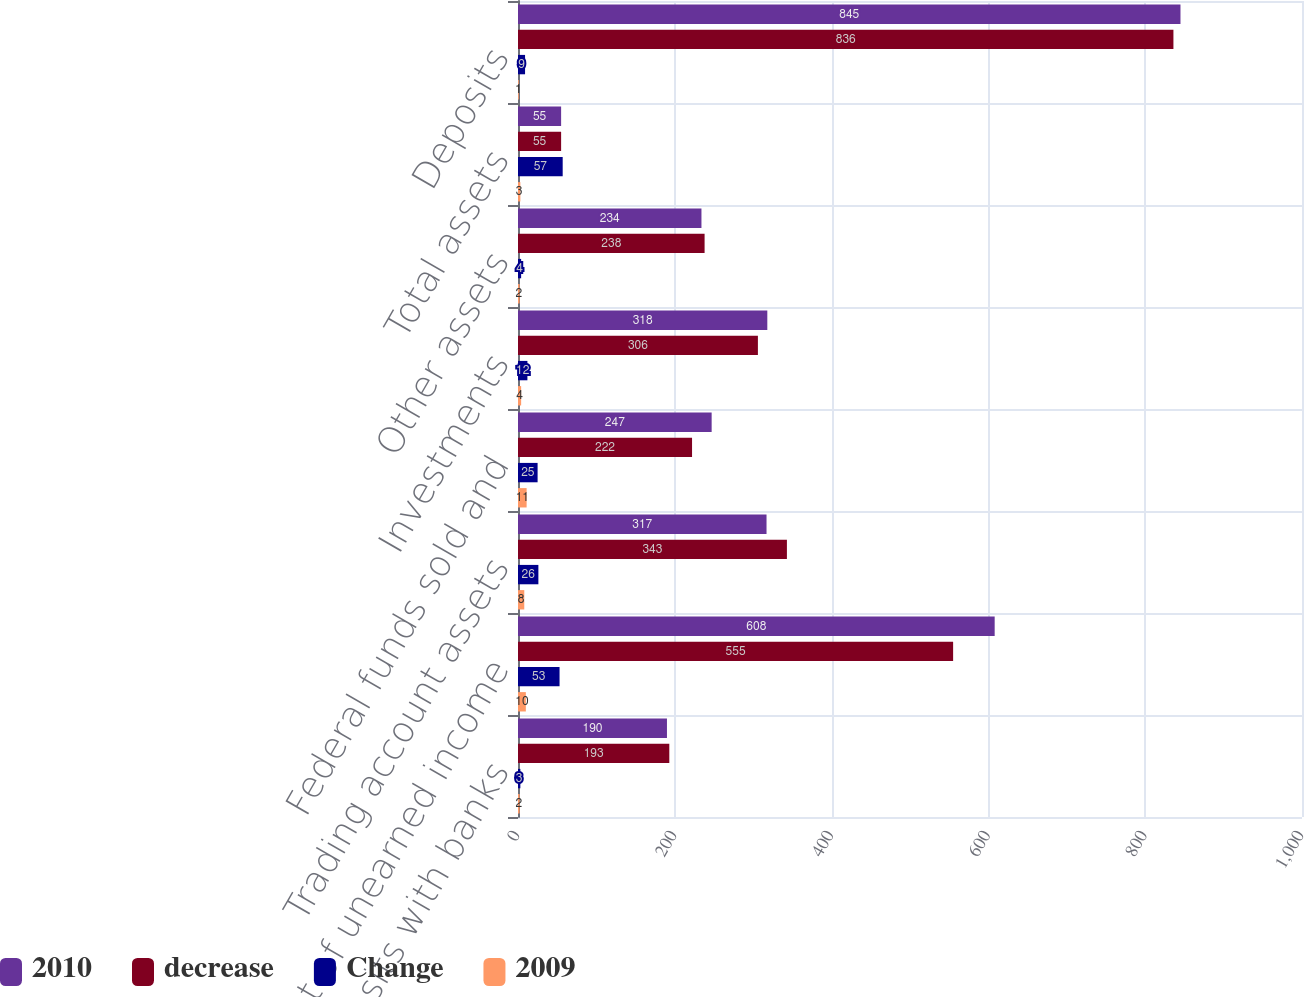Convert chart. <chart><loc_0><loc_0><loc_500><loc_500><stacked_bar_chart><ecel><fcel>Cash and deposits with banks<fcel>Loans net of unearned income<fcel>Trading account assets<fcel>Federal funds sold and<fcel>Investments<fcel>Other assets<fcel>Total assets<fcel>Deposits<nl><fcel>2010<fcel>190<fcel>608<fcel>317<fcel>247<fcel>318<fcel>234<fcel>55<fcel>845<nl><fcel>decrease<fcel>193<fcel>555<fcel>343<fcel>222<fcel>306<fcel>238<fcel>55<fcel>836<nl><fcel>Change<fcel>3<fcel>53<fcel>26<fcel>25<fcel>12<fcel>4<fcel>57<fcel>9<nl><fcel>2009<fcel>2<fcel>10<fcel>8<fcel>11<fcel>4<fcel>2<fcel>3<fcel>1<nl></chart> 